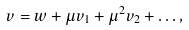<formula> <loc_0><loc_0><loc_500><loc_500>v = w + \mu v _ { 1 } + \mu ^ { 2 } v _ { 2 } + \dots ,</formula> 